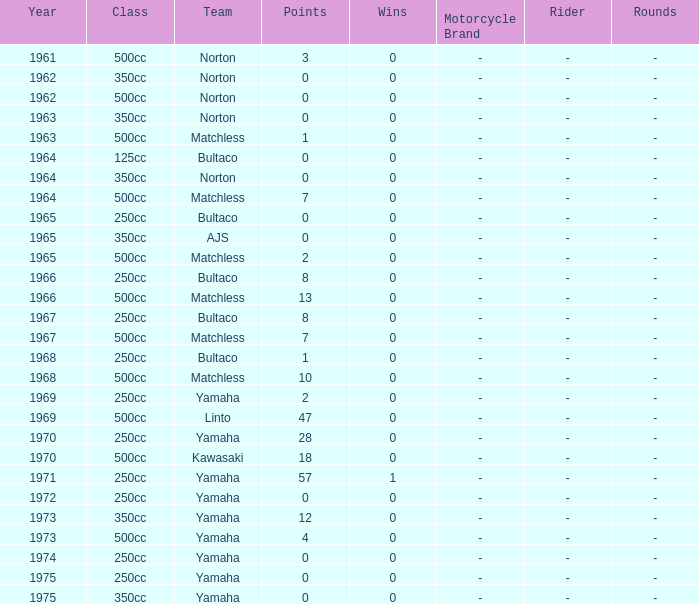What is the average wins in 250cc class for Bultaco with 8 points later than 1966? 0.0. 